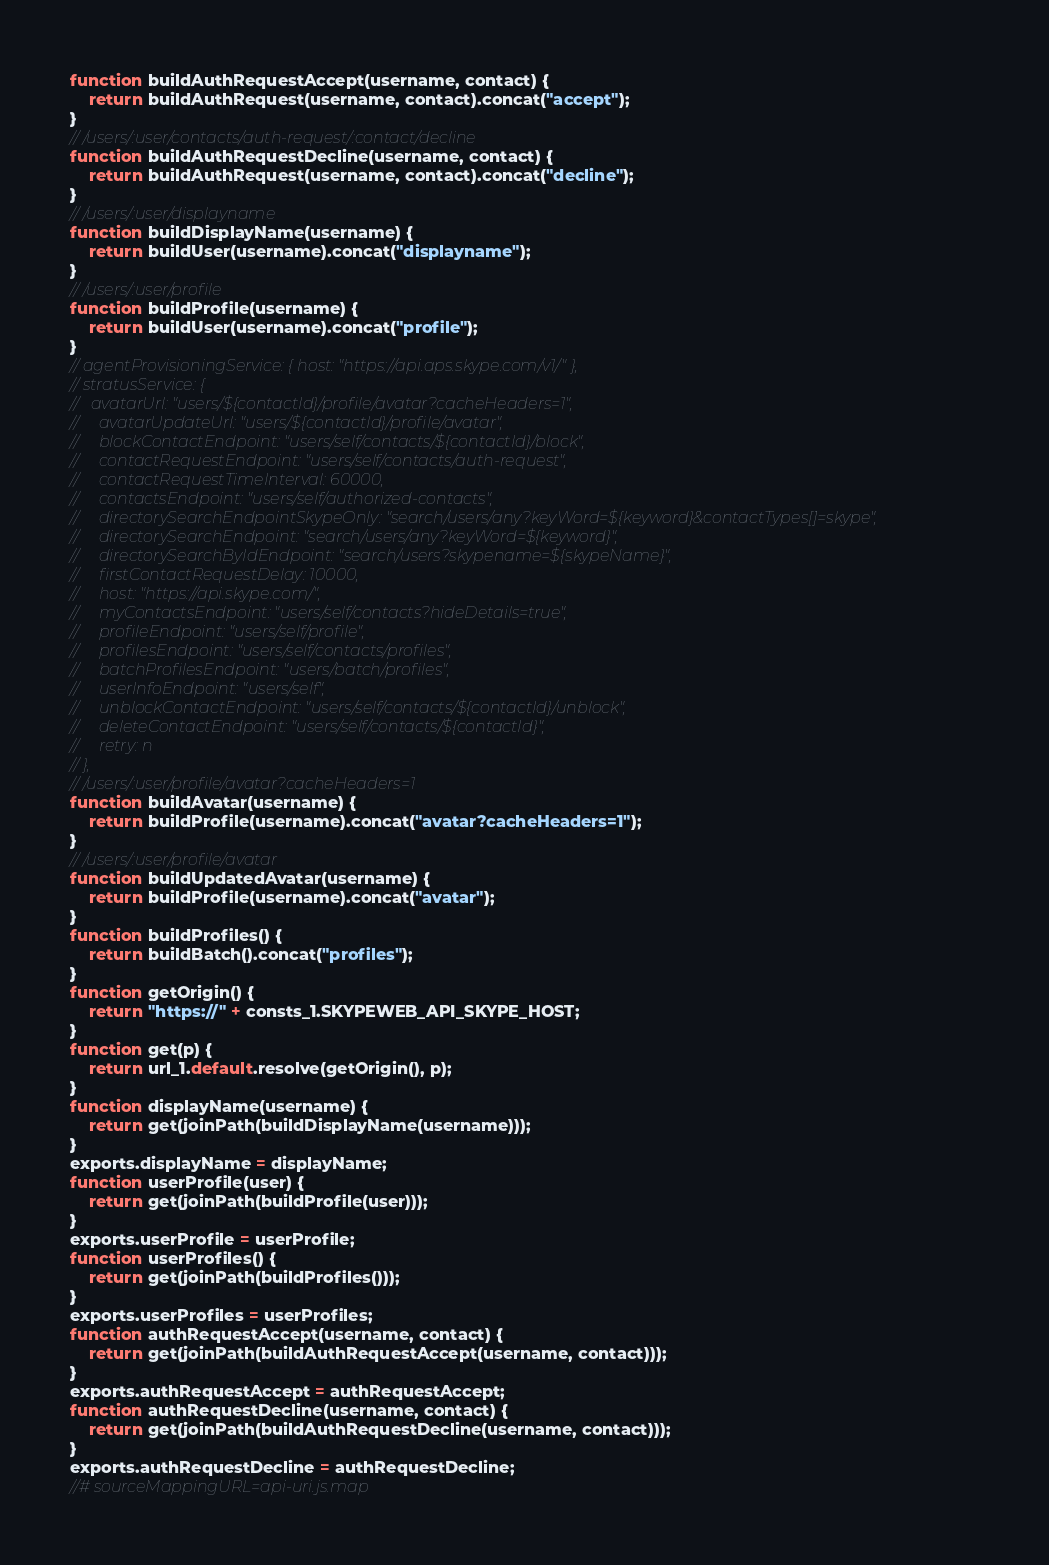Convert code to text. <code><loc_0><loc_0><loc_500><loc_500><_JavaScript_>function buildAuthRequestAccept(username, contact) {
    return buildAuthRequest(username, contact).concat("accept");
}
// /users/:user/contacts/auth-request/:contact/decline
function buildAuthRequestDecline(username, contact) {
    return buildAuthRequest(username, contact).concat("decline");
}
// /users/:user/displayname
function buildDisplayName(username) {
    return buildUser(username).concat("displayname");
}
// /users/:user/profile
function buildProfile(username) {
    return buildUser(username).concat("profile");
}
// agentProvisioningService: { host: "https://api.aps.skype.com/v1/" },
// stratusService: {
//   avatarUrl: "users/${contactId}/profile/avatar?cacheHeaders=1",
//     avatarUpdateUrl: "users/${contactId}/profile/avatar",
//     blockContactEndpoint: "users/self/contacts/${contactId}/block",
//     contactRequestEndpoint: "users/self/contacts/auth-request",
//     contactRequestTimeInterval: 60000,
//     contactsEndpoint: "users/self/authorized-contacts",
//     directorySearchEndpointSkypeOnly: "search/users/any?keyWord=${keyword}&contactTypes[]=skype",
//     directorySearchEndpoint: "search/users/any?keyWord=${keyword}",
//     directorySearchByIdEndpoint: "search/users?skypename=${skypeName}",
//     firstContactRequestDelay: 10000,
//     host: "https://api.skype.com/",
//     myContactsEndpoint: "users/self/contacts?hideDetails=true",
//     profileEndpoint: "users/self/profile",
//     profilesEndpoint: "users/self/contacts/profiles",
//     batchProfilesEndpoint: "users/batch/profiles",
//     userInfoEndpoint: "users/self",
//     unblockContactEndpoint: "users/self/contacts/${contactId}/unblock",
//     deleteContactEndpoint: "users/self/contacts/${contactId}",
//     retry: n
// },
// /users/:user/profile/avatar?cacheHeaders=1
function buildAvatar(username) {
    return buildProfile(username).concat("avatar?cacheHeaders=1");
}
// /users/:user/profile/avatar
function buildUpdatedAvatar(username) {
    return buildProfile(username).concat("avatar");
}
function buildProfiles() {
    return buildBatch().concat("profiles");
}
function getOrigin() {
    return "https://" + consts_1.SKYPEWEB_API_SKYPE_HOST;
}
function get(p) {
    return url_1.default.resolve(getOrigin(), p);
}
function displayName(username) {
    return get(joinPath(buildDisplayName(username)));
}
exports.displayName = displayName;
function userProfile(user) {
    return get(joinPath(buildProfile(user)));
}
exports.userProfile = userProfile;
function userProfiles() {
    return get(joinPath(buildProfiles()));
}
exports.userProfiles = userProfiles;
function authRequestAccept(username, contact) {
    return get(joinPath(buildAuthRequestAccept(username, contact)));
}
exports.authRequestAccept = authRequestAccept;
function authRequestDecline(username, contact) {
    return get(joinPath(buildAuthRequestDecline(username, contact)));
}
exports.authRequestDecline = authRequestDecline;
//# sourceMappingURL=api-uri.js.map</code> 